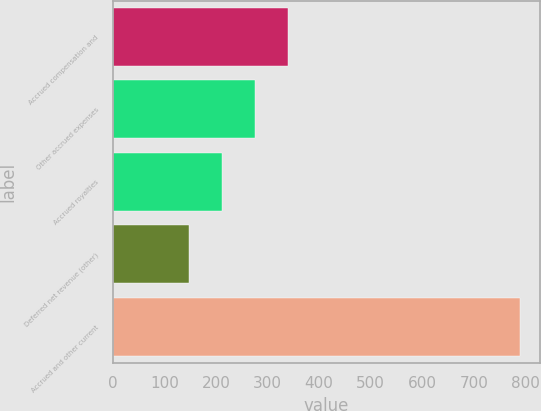<chart> <loc_0><loc_0><loc_500><loc_500><bar_chart><fcel>Accrued compensation and<fcel>Other accrued expenses<fcel>Accrued royalties<fcel>Deferred net revenue (other)<fcel>Accrued and other current<nl><fcel>339.6<fcel>275.4<fcel>211.2<fcel>147<fcel>789<nl></chart> 